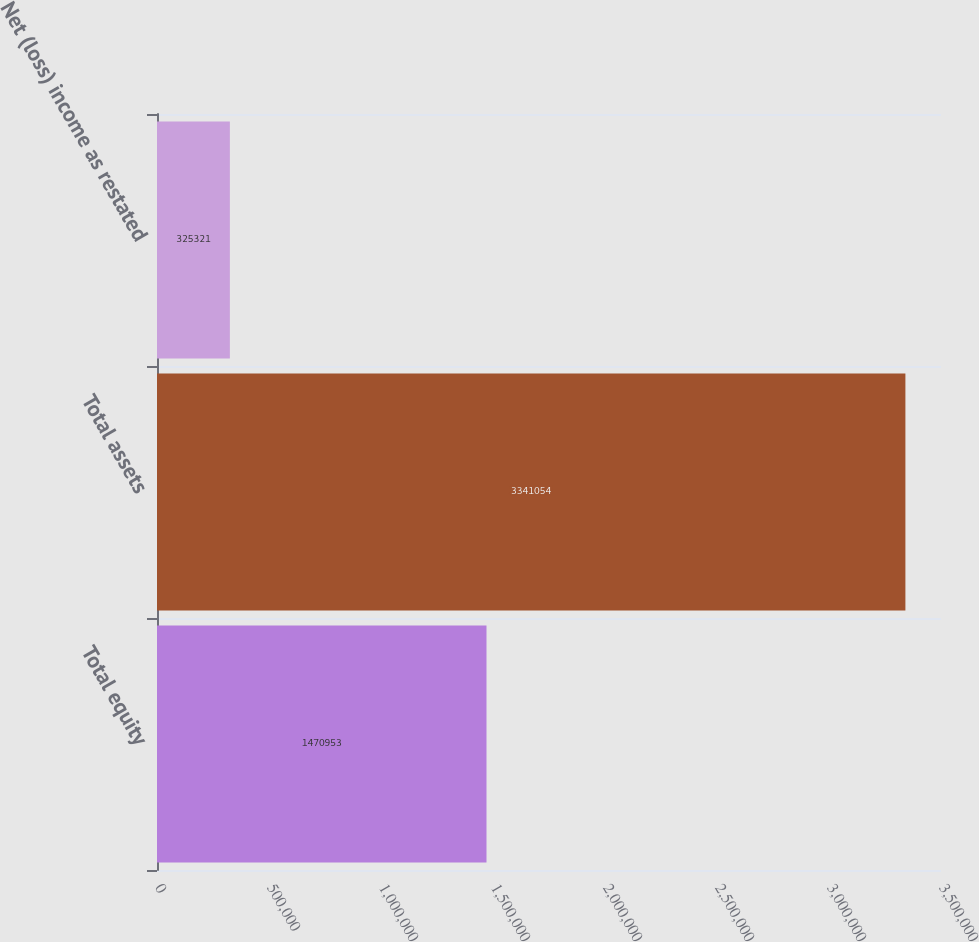<chart> <loc_0><loc_0><loc_500><loc_500><bar_chart><fcel>Total equity<fcel>Total assets<fcel>Net (loss) income as restated<nl><fcel>1.47095e+06<fcel>3.34105e+06<fcel>325321<nl></chart> 